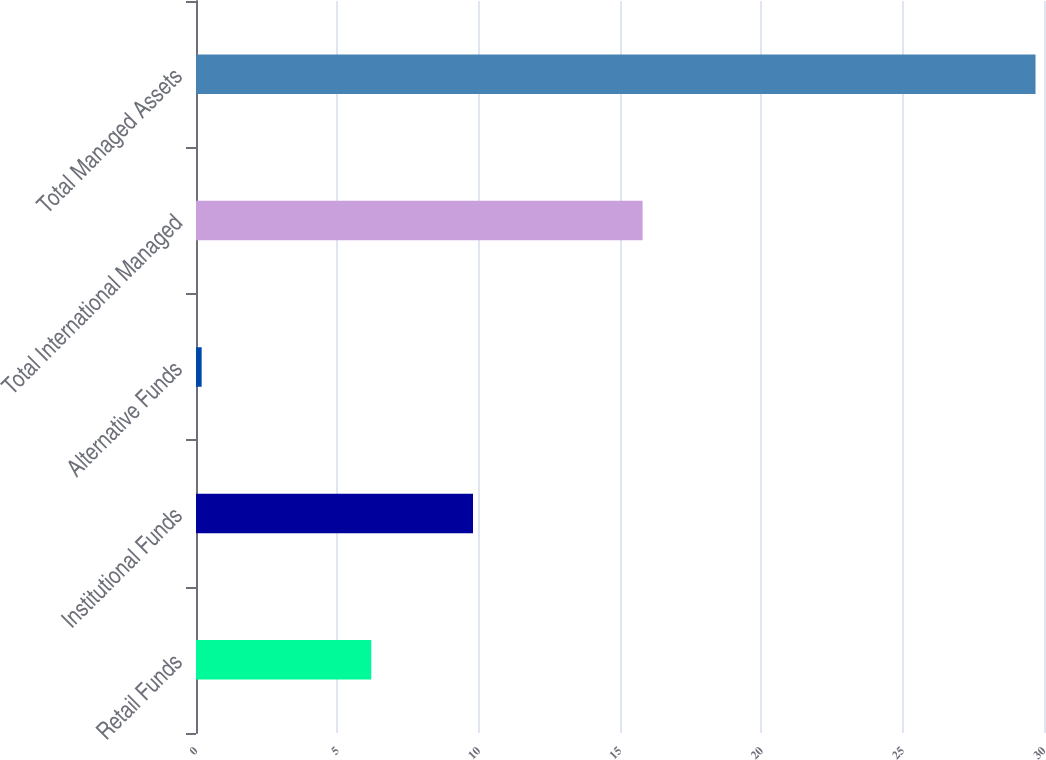Convert chart to OTSL. <chart><loc_0><loc_0><loc_500><loc_500><bar_chart><fcel>Retail Funds<fcel>Institutional Funds<fcel>Alternative Funds<fcel>Total International Managed<fcel>Total Managed Assets<nl><fcel>6.2<fcel>9.8<fcel>0.2<fcel>15.8<fcel>29.7<nl></chart> 